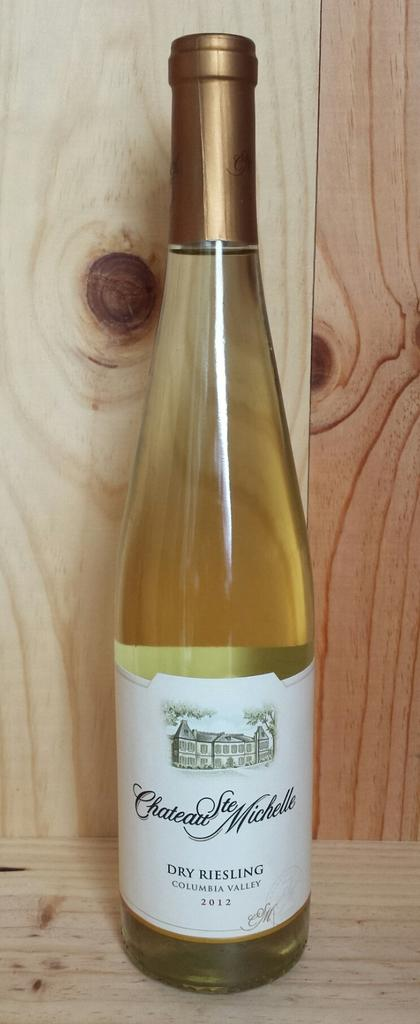<image>
Offer a succinct explanation of the picture presented. A bottle of white wine which is from Columbia valley. 